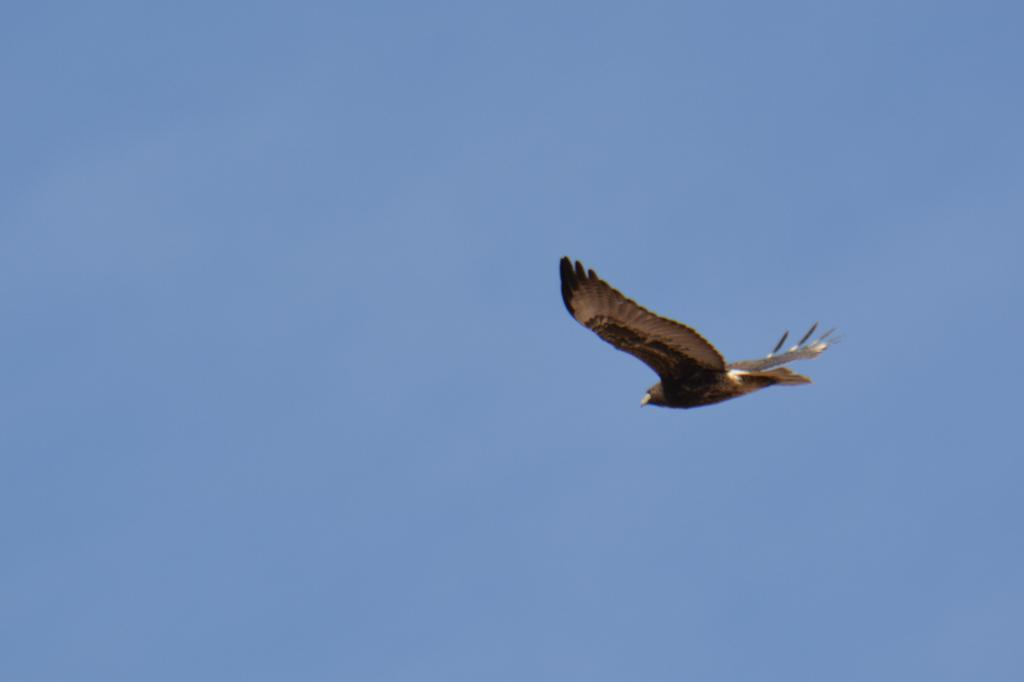What animal can be seen in the image? There is a bird in the image. What is the bird doing in the image? The bird is flying in the image. Where is the bird located in the image? The bird is in the sky in the image. What is the condition of the sky in the image? The sky is clear in the image. What type of agreement is being signed by the bird in the image? There is no agreement being signed in the image; it features a bird flying in the sky. What type of protest is the bird participating in the image? There is no protest depicted in the image; it features a bird flying in the sky. 